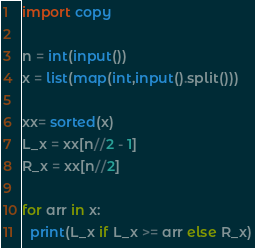<code> <loc_0><loc_0><loc_500><loc_500><_Python_>import copy

n = int(input())
x = list(map(int,input().split()))

xx= sorted(x)
L_x = xx[n//2 - 1]
R_x = xx[n//2]

for arr in x:
  print(L_x if L_x >= arr else R_x)</code> 